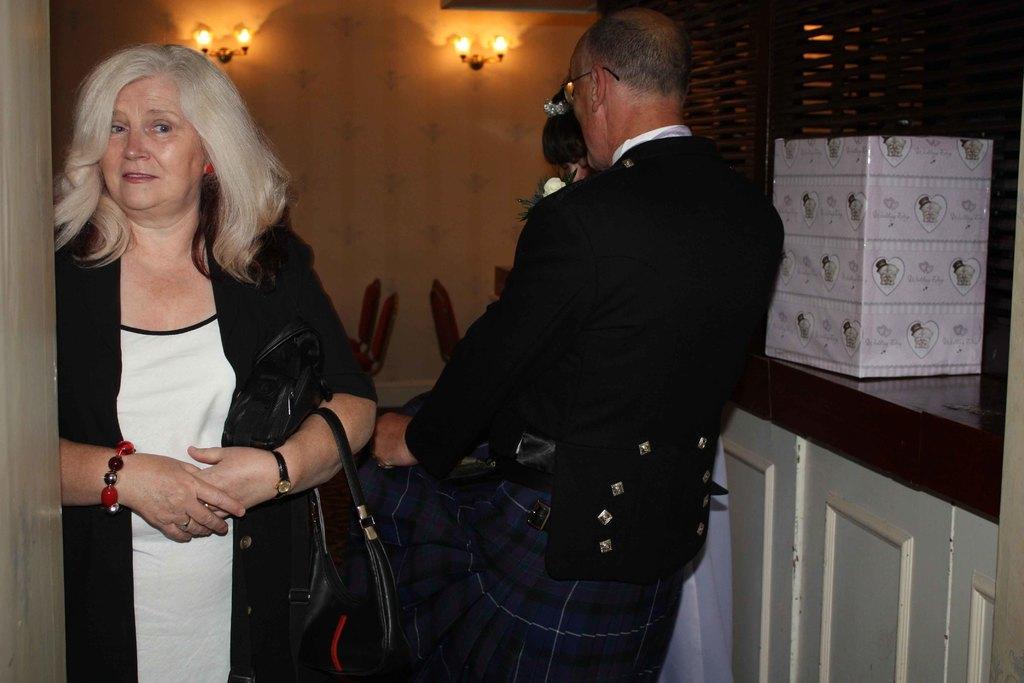Can you describe this image briefly? In this image we can see one man and a woman. The man is wearing a black color coat and woman is wearing white and black color dress and carrying black color bag. We can see cupboard on the right side of the image and there is one box. We can see chairs in the background and lights are attached to the wall. 